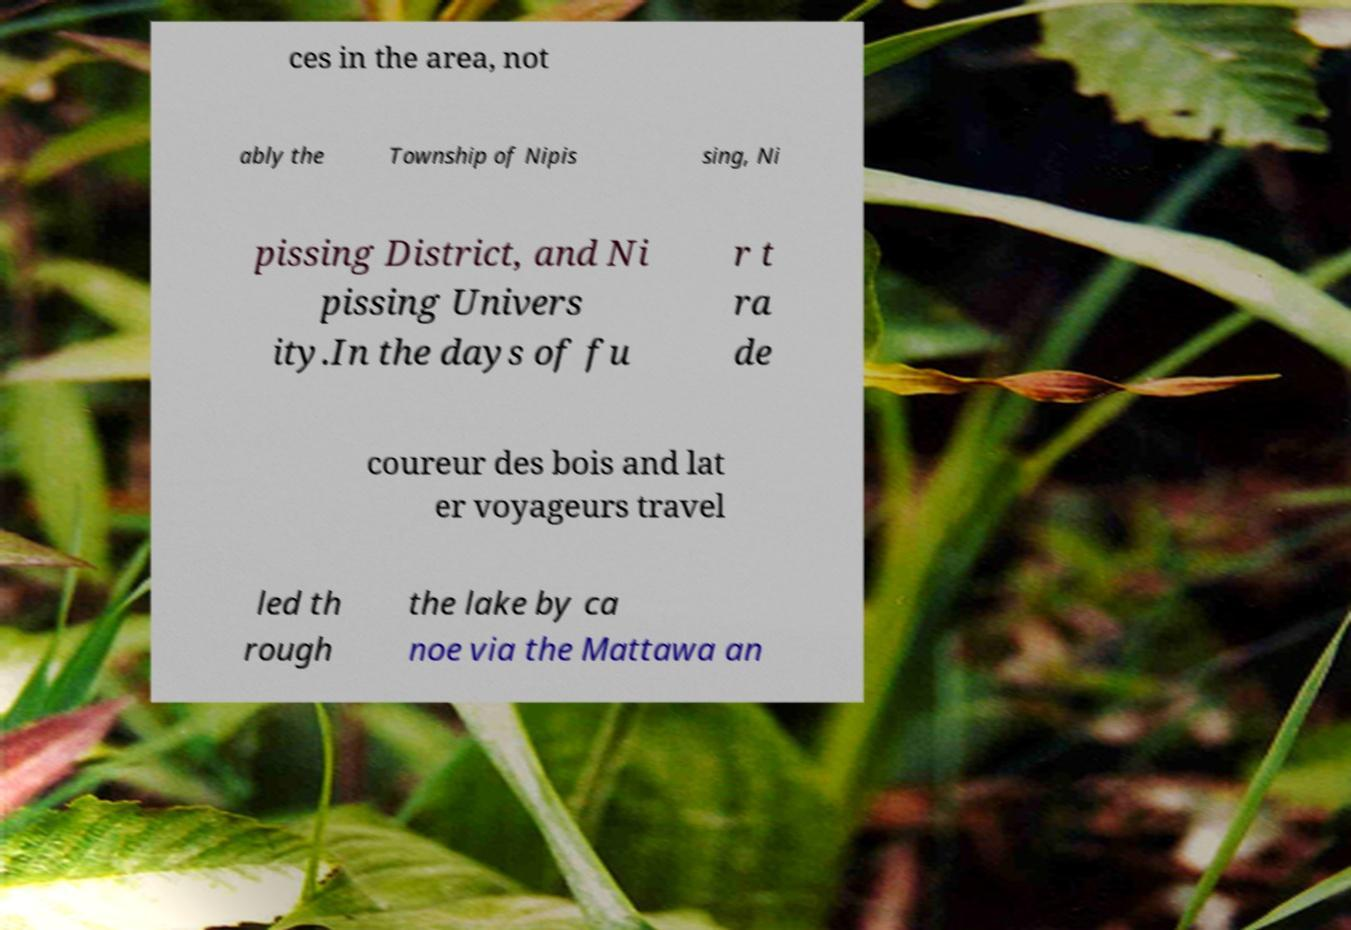Could you assist in decoding the text presented in this image and type it out clearly? ces in the area, not ably the Township of Nipis sing, Ni pissing District, and Ni pissing Univers ity.In the days of fu r t ra de coureur des bois and lat er voyageurs travel led th rough the lake by ca noe via the Mattawa an 